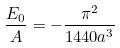<formula> <loc_0><loc_0><loc_500><loc_500>\frac { E _ { 0 } } { A } = - \frac { \pi ^ { 2 } } { 1 4 4 0 a ^ { 3 } }</formula> 